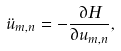Convert formula to latex. <formula><loc_0><loc_0><loc_500><loc_500>\ddot { u } _ { m , n } = - \frac { \partial H } { \partial u _ { m , n } } ,</formula> 